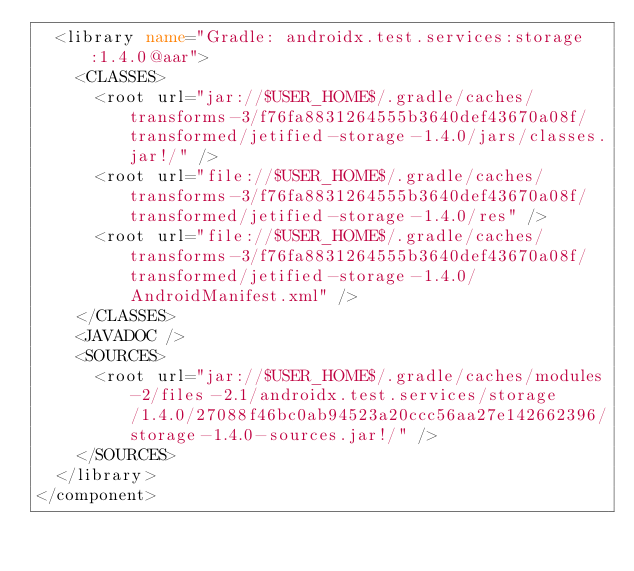Convert code to text. <code><loc_0><loc_0><loc_500><loc_500><_XML_>  <library name="Gradle: androidx.test.services:storage:1.4.0@aar">
    <CLASSES>
      <root url="jar://$USER_HOME$/.gradle/caches/transforms-3/f76fa8831264555b3640def43670a08f/transformed/jetified-storage-1.4.0/jars/classes.jar!/" />
      <root url="file://$USER_HOME$/.gradle/caches/transforms-3/f76fa8831264555b3640def43670a08f/transformed/jetified-storage-1.4.0/res" />
      <root url="file://$USER_HOME$/.gradle/caches/transforms-3/f76fa8831264555b3640def43670a08f/transformed/jetified-storage-1.4.0/AndroidManifest.xml" />
    </CLASSES>
    <JAVADOC />
    <SOURCES>
      <root url="jar://$USER_HOME$/.gradle/caches/modules-2/files-2.1/androidx.test.services/storage/1.4.0/27088f46bc0ab94523a20ccc56aa27e142662396/storage-1.4.0-sources.jar!/" />
    </SOURCES>
  </library>
</component></code> 